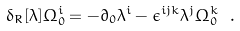<formula> <loc_0><loc_0><loc_500><loc_500>\delta _ { R } [ \lambda ] \Omega ^ { i } _ { 0 } = - \partial _ { 0 } \lambda ^ { i } - \epsilon ^ { i j k } \lambda ^ { j } \Omega ^ { k } _ { 0 } \ .</formula> 